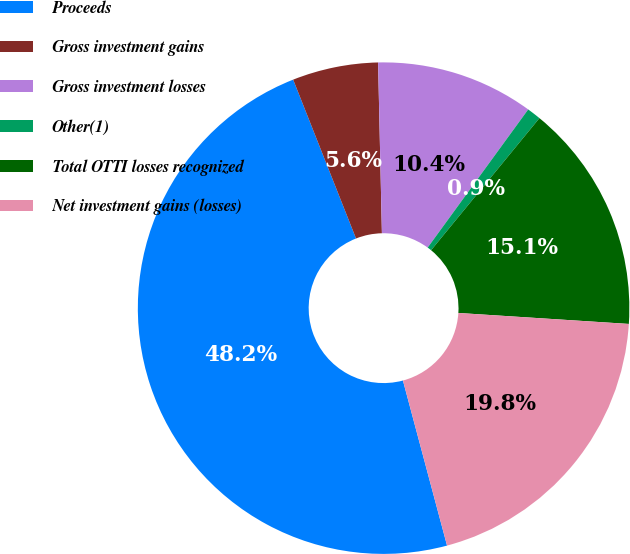<chart> <loc_0><loc_0><loc_500><loc_500><pie_chart><fcel>Proceeds<fcel>Gross investment gains<fcel>Gross investment losses<fcel>Other(1)<fcel>Total OTTI losses recognized<fcel>Net investment gains (losses)<nl><fcel>48.16%<fcel>5.64%<fcel>10.37%<fcel>0.92%<fcel>15.09%<fcel>19.82%<nl></chart> 